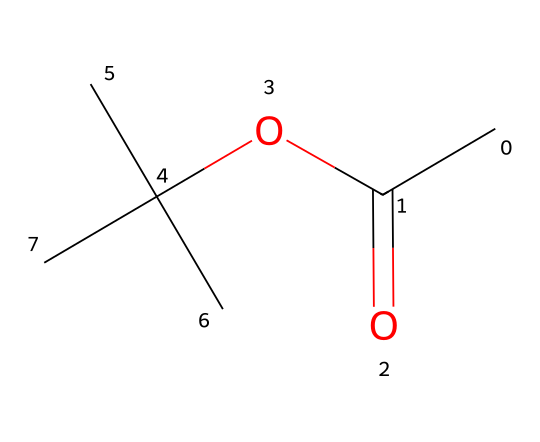what is the molecular formula of this compound? To determine the molecular formula, we count the number of each type of atom in the SMILES representation. The representation CC(=O)OC(C)(C)C indicates that there are 7 carbon (C) atoms, 14 hydrogen (H) atoms, and 2 oxygen (O) atoms. Thus, the molecular formula is C7H14O2.
Answer: C7H14O2 what functional groups are present in this compound? By analyzing the structure represented in SMILES, we can identify that there is an ester group (due to the -COO- linkage) and a carbonyl group (C=O) within the ester.
Answer: ester, carbonyl how many tertiary carbons are in this compound? A tertiary carbon is one bonded to three other carbon atoms. From the structure, we can identify that there are three such carbons in the branched alkyl groups (C(C)(C)).
Answer: 3 what is the primary type of bonding in this compound? The bonding in organic compounds like this one is primarily covalent bonding, which exists between carbon and other atoms (hydrogens and oxygens).
Answer: covalent which part of the molecule determines its eco-friendliness as a dry cleaning solvent? The presence of the ester functional group suggests that this compound might be a less toxic and more biodegradable option compared to traditional chlorinated solvents. Esters generally have more favorable environmental profiles.
Answer: ester functional group how many double bonds are present in this compound? By examining the SMILES, the only double bond present is in the carbonyl group (C=O). Therefore, we conclude that there is one double bond in the structure.
Answer: 1 